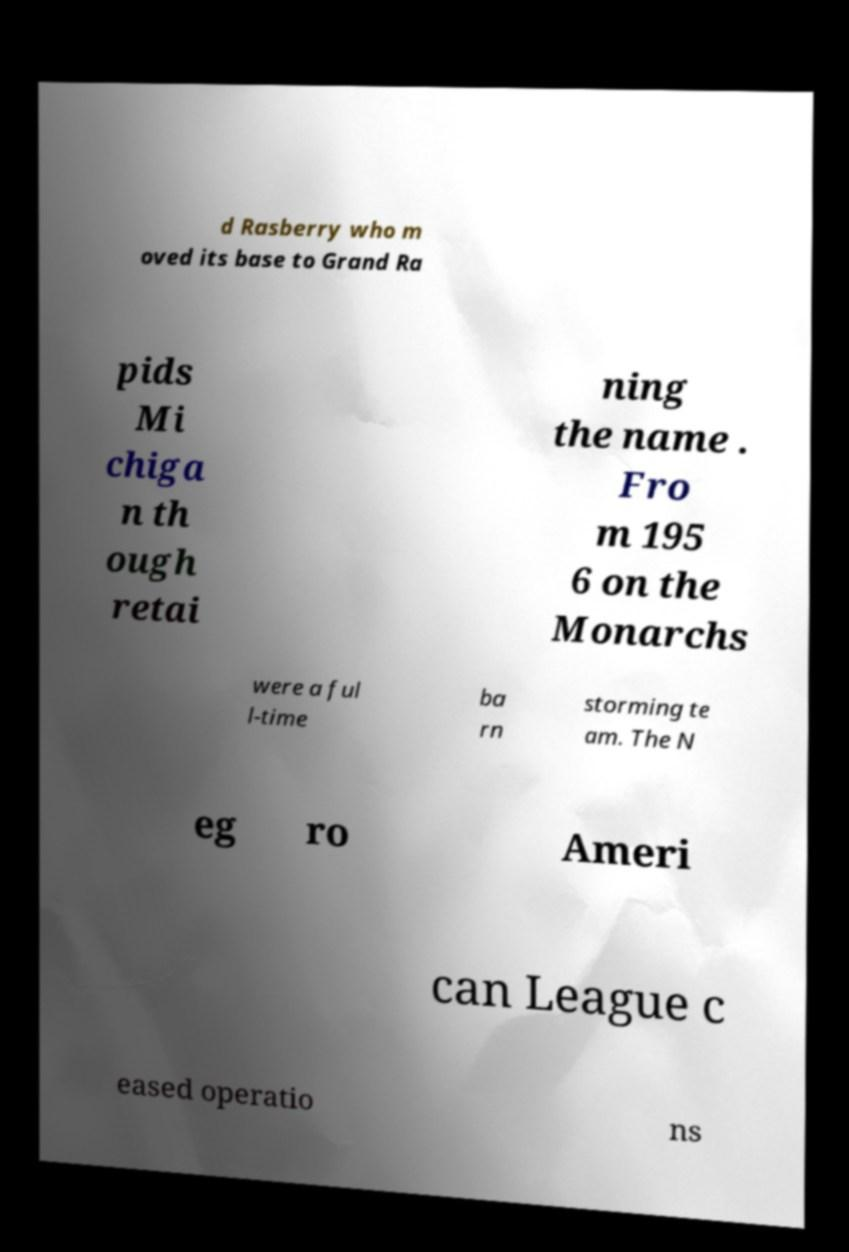Can you read and provide the text displayed in the image?This photo seems to have some interesting text. Can you extract and type it out for me? d Rasberry who m oved its base to Grand Ra pids Mi chiga n th ough retai ning the name . Fro m 195 6 on the Monarchs were a ful l-time ba rn storming te am. The N eg ro Ameri can League c eased operatio ns 